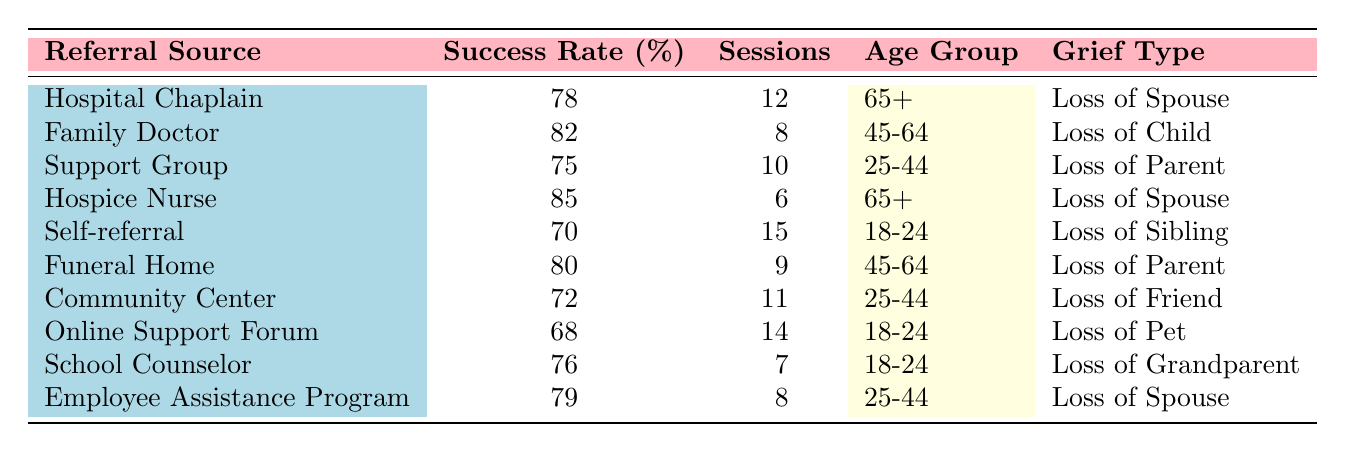What is the success rate of the Funeral Home as a referral source? From the table, we can directly locate the row for "Funeral Home" and find its success rate listed as 80%.
Answer: 80% Which age group has the highest success rate among referral sources? To determine the highest success rate, we examine the success rates for each age group: 78% (65+), 82% (45-64), 85% (65+), 70% (18-24), 80% (45-64), 72% (25-44), 68% (18-24), 76% (18-24). The highest success rate is 85% for the age group 65+ (Hospice Nurse).
Answer: 65+ Is the success rate of the Self-referral higher than the Community Center? The Self-referral has a success rate of 70% while the Community Center has a success rate of 72%. Since 70% is less than 72%, the statement is false.
Answer: No What is the average success rate for all referral sources? To find the average, we sum all success rates from the table: 78 + 82 + 75 + 85 + 70 + 80 + 72 + 68 + 76 + 79 =  79.5, and then divide by the number of sources (10). Therefore, the average success rate is 795/10 = 79.5%.
Answer: 79.5% Which grief type has the most sessions completed? By reviewing the total sessions for each grief type: Loss of Sibling (15), Loss of Friend (11), Loss of Spouse (12 + 6 + 8 = 26), Loss of Parent (10 + 9 = 19), and Loss of Child (8). The grief type “Loss of Spouse” has the highest total of 26 sessions.
Answer: Loss of Spouse Does the Hospice Nurse have more experience than the Family Doctor? Both the Hospice Nurse and Family Doctor have counselor experience listed as 15 years. Therefore, they have the same experience.
Answer: No Among the referral sources, what percentage of cases were related to Loss of Spouse? There are three cases related to Loss of Spouse out of ten total records. Therefore, we calculate (3/10) * 100 = 30%.
Answer: 30% What is the difference between the highest and lowest success rates among the referral sources? The highest success rate is 85% (Hospice Nurse) and the lowest is 68% (Online Support Forum). The difference is calculated as 85% - 68% = 17%.
Answer: 17% 